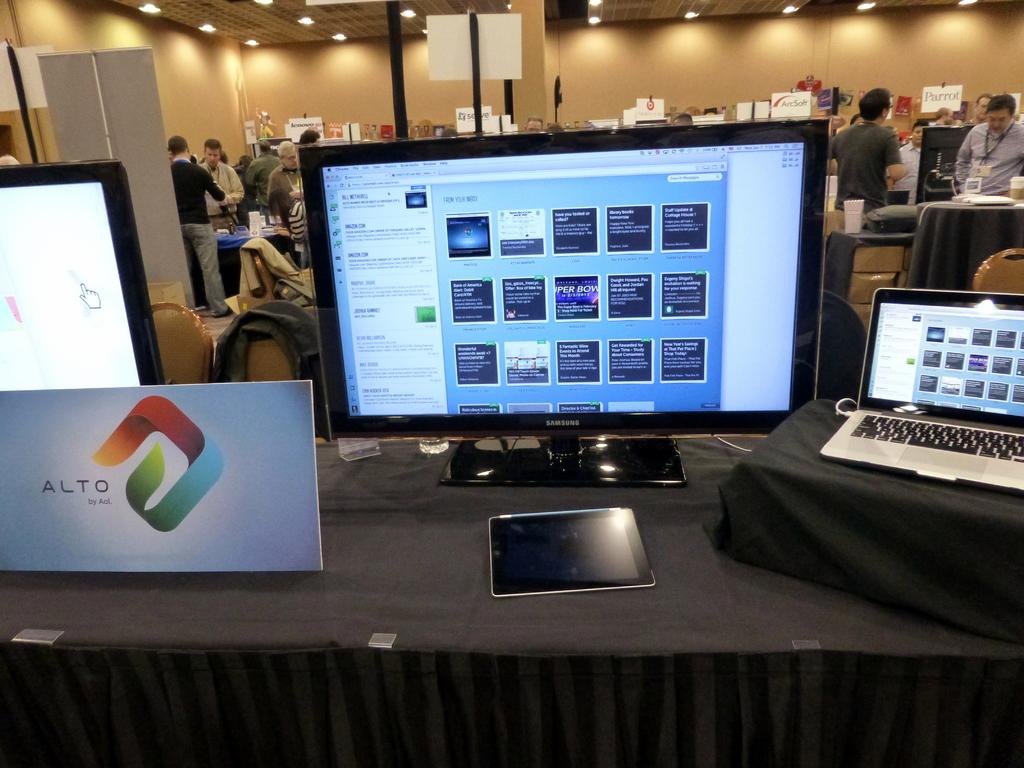What brand is on the box?
Provide a succinct answer. Alto. 